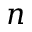<formula> <loc_0><loc_0><loc_500><loc_500>n</formula> 